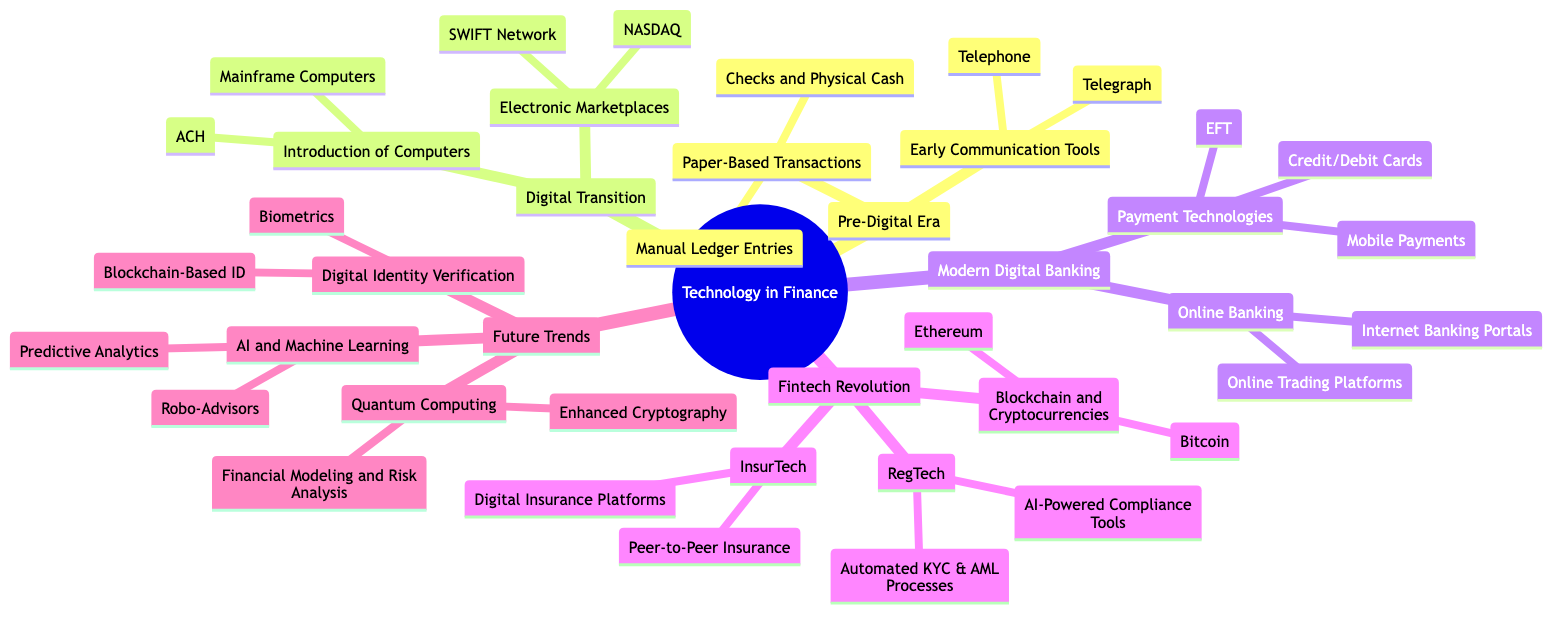What are the two major eras in the diagram? The diagram identifies four main sections, but the first two are prominently labeled as "Pre-Digital Era" and "Digital Transition". These sections represent significant periods in the advancement of technology in the finance industry.
Answer: Pre-Digital Era, Digital Transition How many children does the "Fintech Revolution" node have? By inspecting the "Fintech Revolution" section of the diagram, it reveals three direct children: "Blockchain and Cryptocurrencies," "RegTech," and "InsurTech." This indicates that there are three components within this segment of finance technology.
Answer: 3 Which technology is associated with "Digital Identity Verification"? In the diagram, "Digital Identity Verification" is directly linked to two child technologies: "Biometrics" and "Blockchain-Based ID." Evaluating these associations leads us to specify the technology of interest.
Answer: Biometrics, Blockchain-Based ID What is the relationship between "Online Banking" and "Payment Technologies"? Both "Online Banking" and "Payment Technologies" are children of the "Modern Digital Banking" parent node. This indicates that they are part of the same larger category within the finance technology progression, emphasizing their collective role in modern banking frameworks.
Answer: Siblings List one technology under the "Future Trends" category. The "Future Trends" section includes multiple technologies, such as "Artificial Intelligence and Machine Learning", "Digital Identity Verification", and "Quantum Computing." Selecting any one of these technologies provides the answer to the query.
Answer: Artificial Intelligence and Machine Learning What type of transactions does "Payment Technologies" include? Within the "Payment Technologies" node, three specific technologies are mentioned, signifying their role in financial transactions: "Credit/Debit Cards," "Electronic Funds Transfer," and "Mobile Payments." These indicate the tools and methods employed for modern electronic transactions.
Answer: Credit/Debit Cards, Electronic Funds Transfer, Mobile Payments Identify a child technology of "Electronic Marketplaces". Within the "Electronic Marketplaces" segment of the diagram, two associated technologies are present: "NASDAQ" and "SWIFT Network." By pinpointing either of these, we can directly answer the question related to child technologies under this category.
Answer: NASDAQ How many total child nodes are listed under "Digital Transition"? The "Digital Transition" node comprises two primary sections: "Introduction of Computers" and "Electronic Marketplaces." Each of these has its own child nodes: "Introduction of Computers" has two, and "Electronic Marketplaces" also has two. Thus, a simple addition (2+2) provides the total count of child nodes.
Answer: 4 